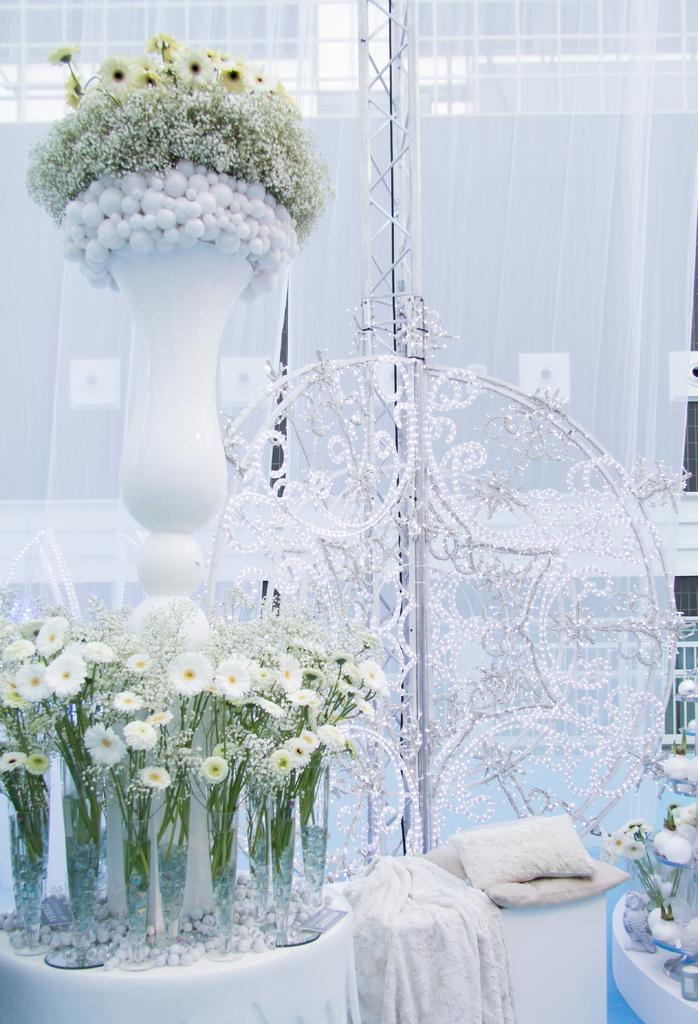What object is placed on the table in the image? There is a flower vase on the table. What type of window treatment can be seen in the image? There are curtains visible in the image. What type of fish can be seen swimming in the snow in the image? There is no fish or snow present in the image; it only features a flower vase on the table and curtains. 